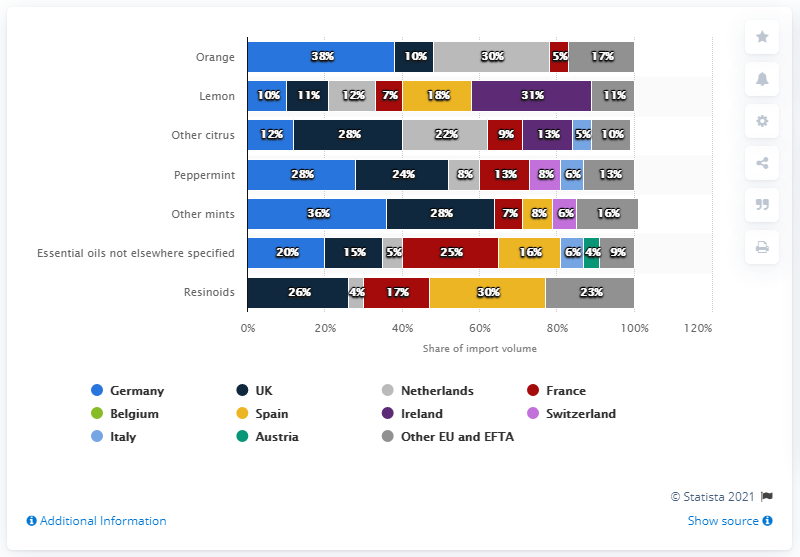Draw attention to some important aspects in this diagram. The chart shows the representation of various countries' flags, with Spain represented by the color yellow. The highest value of lemon oil is different from the lowest value of orange oil by 26. 